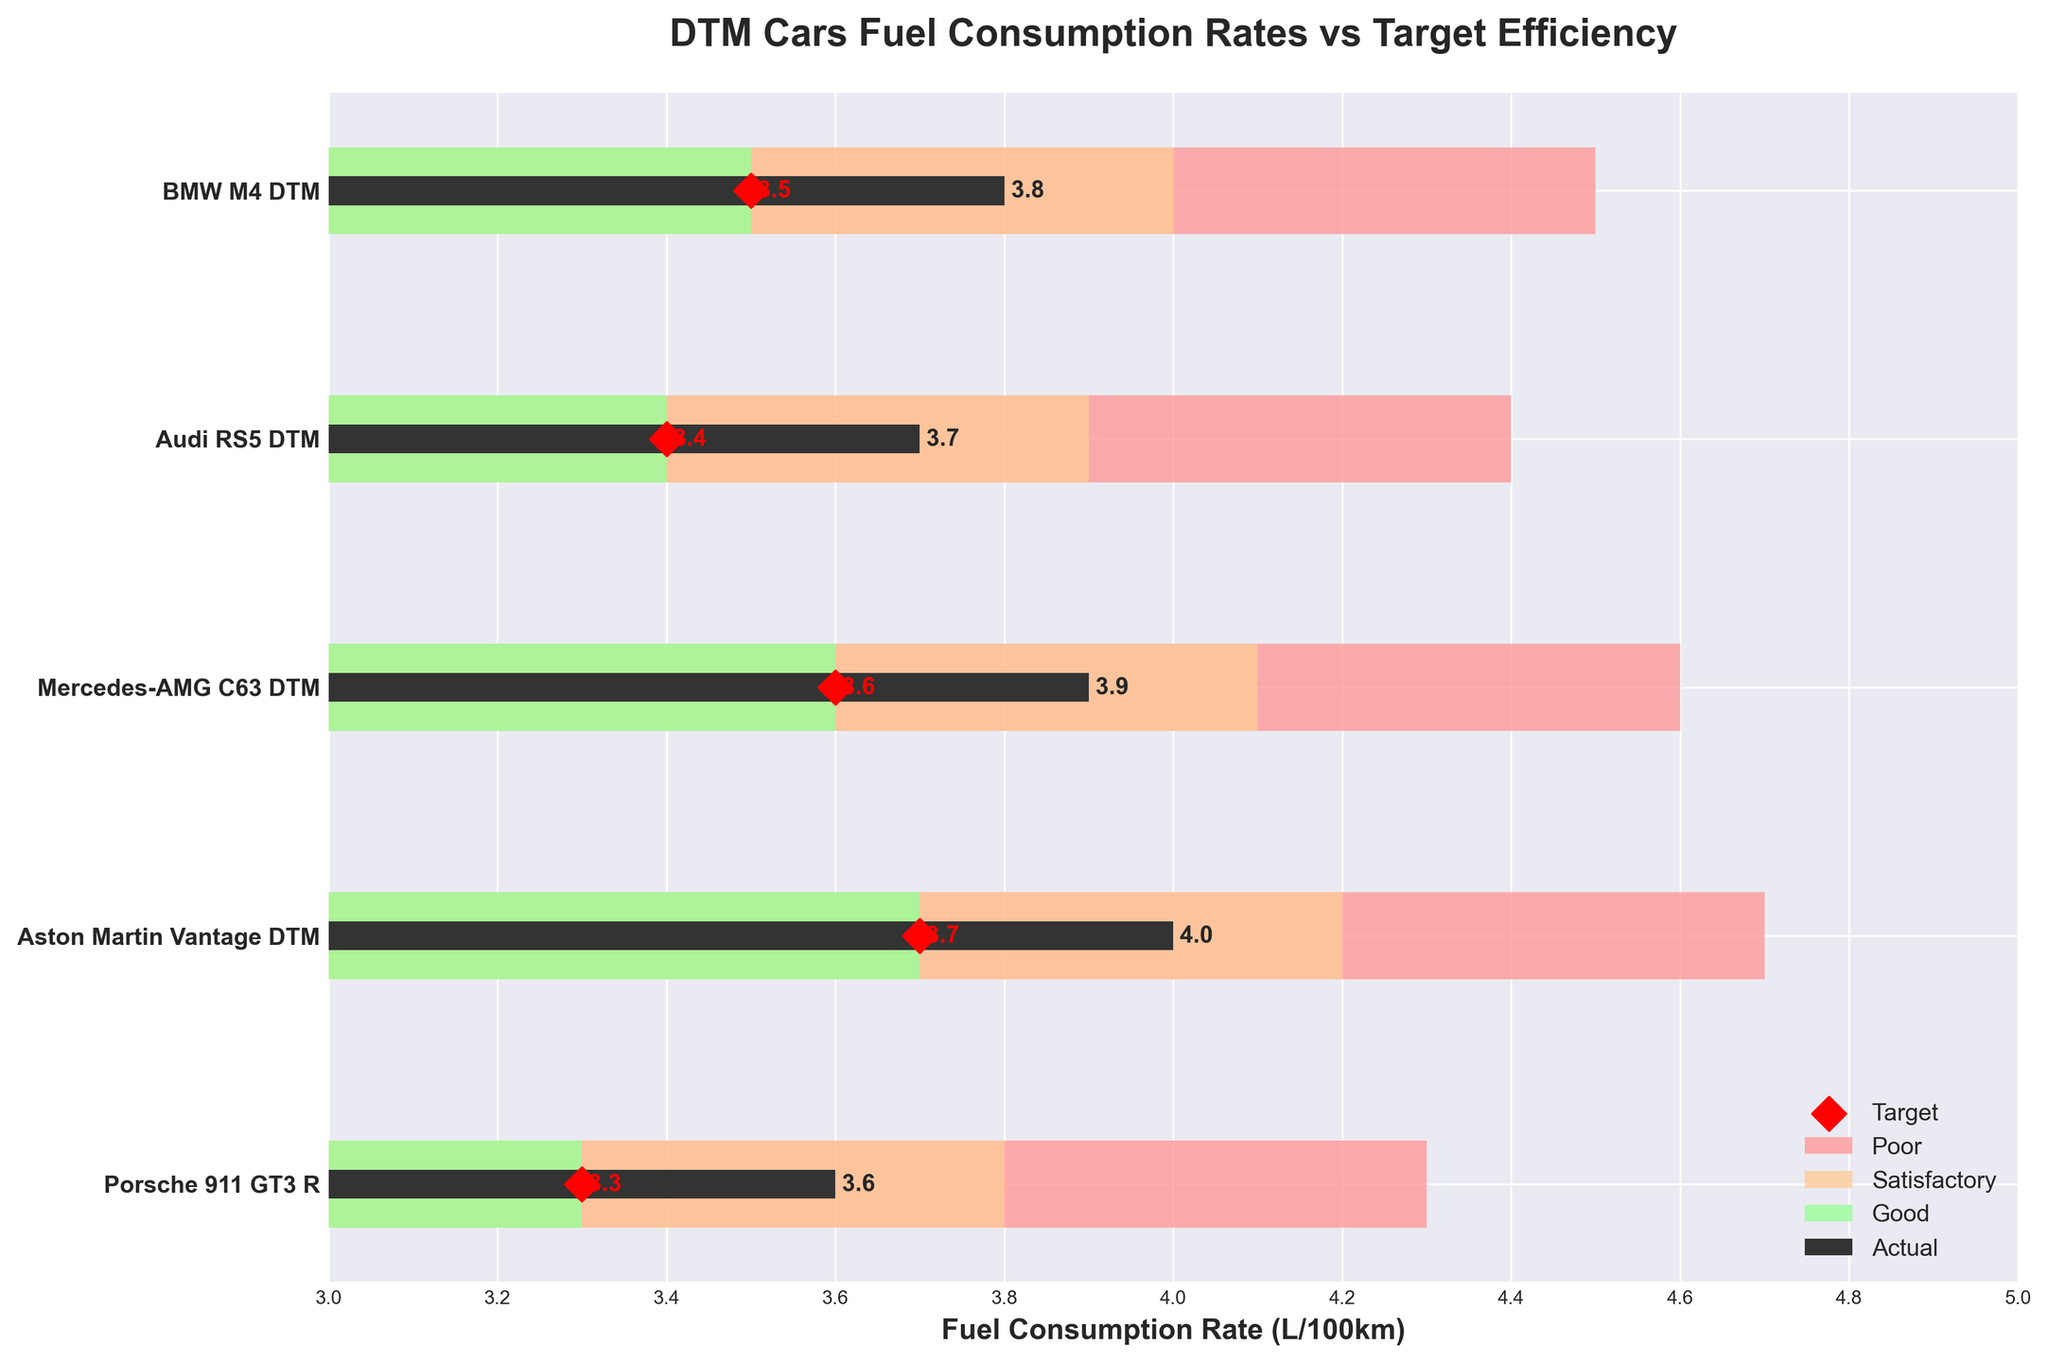What is the title of the figure? The title of the figure is written at the top center of the plot. It reads: "DTM Cars Fuel Consumption Rates vs Target Efficiency".
Answer: DTM Cars Fuel Consumption Rates vs Target Efficiency What colors are used to indicate the 'Poor', 'Satisfactory', and 'Good' fuel efficiency levels? The plot uses different colors to indicate fuel efficiency levels: 'Poor' is shown in light red, 'Satisfactory' in light orange, and 'Good' in light green.
Answer: Light red for Poor, light orange for Satisfactory, light green for Good Which DTM car has the highest actual fuel consumption rate? The plot shows the actual fuel consumption rates for each car. Aston Martin Vantage DTM has the highest actual rate at 4.0 L/100km.
Answer: Aston Martin Vantage DTM How does the actual fuel consumption of the BMW M4 DTM compare to its target? The actual fuel consumption rate of the BMW M4 DTM is 3.8 L/100km, which is higher than its target of 3.5 L/100km.
Answer: Higher than its target Which car has its actual fuel consumption rate closest to its target efficiency? By comparing the actual and target rates, we see that the Audi RS5 DTM has a target of 3.4 L/100km and an actual rate of 3.7 L/100km, which is a difference of 0.3. Other cars have larger differences.
Answer: Audi RS5 DTM What's the average actual fuel consumption rate of all the DTM cars? The actual fuel consumption rates are 3.8, 3.7, 3.9, 4.0, and 3.6. Adding these together gives 19.0. There are 5 cars, so the average is 19.0/5 = 3.8.
Answer: 3.8 How many cars meet or exceed their good fuel efficiency target? Cars that meet or exceed good efficiency have actual rates less than or equal to their good target rates. All actual rates need to be less than the 'Good' threshold (3.5, 3.4, 3.6, 3.7, 3.3). Only the Porsche 911 GT3 R meets this with an actual rate of 3.6.
Answer: One car By how much does the Mercedes-AMG C63 DTM miss its target fuel consumption rate? The target for Mercedes-AMG C63 DTM is 3.6 L/100km, and the actual is 3.9 L/100km. The difference is 3.9 - 3.6 = 0.3 L/100km.
Answer: 0.3 L/100km Which car has the actual fuel consumption rate that falls into the 'Poor' efficiency category? The 'Poor' category is above 4.0 L/100km. Aston Martin Vantage DTM has an actual rate of 4.0, falling under this category.
Answer: Aston Martin Vantage DTM 